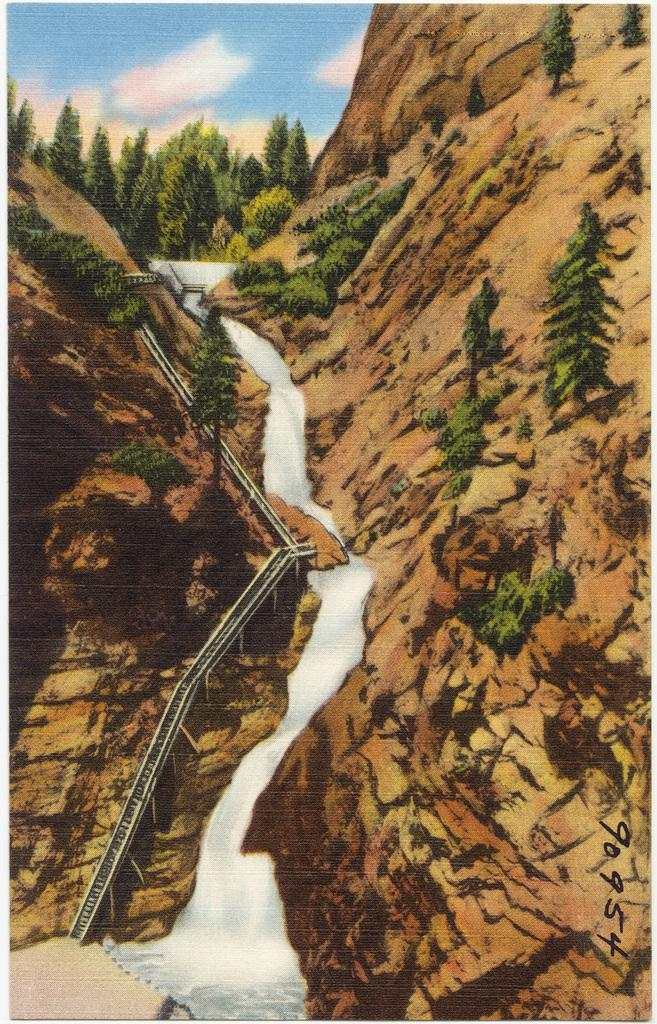What type of picture is the image? The image is an animated picture. What natural elements can be seen in the image? There are trees and a hill in the image. What man-made structure is present in the image? There is a staircase in the image. What water feature can be seen in the image? There is a waterfall in the image. What type of brick is used to build the machine in the image? There is no machine or brick present in the image. What type of journey is depicted in the image? The image does not depict a journey; it is a static scene with trees, a hill, a staircase, and a waterfall. 